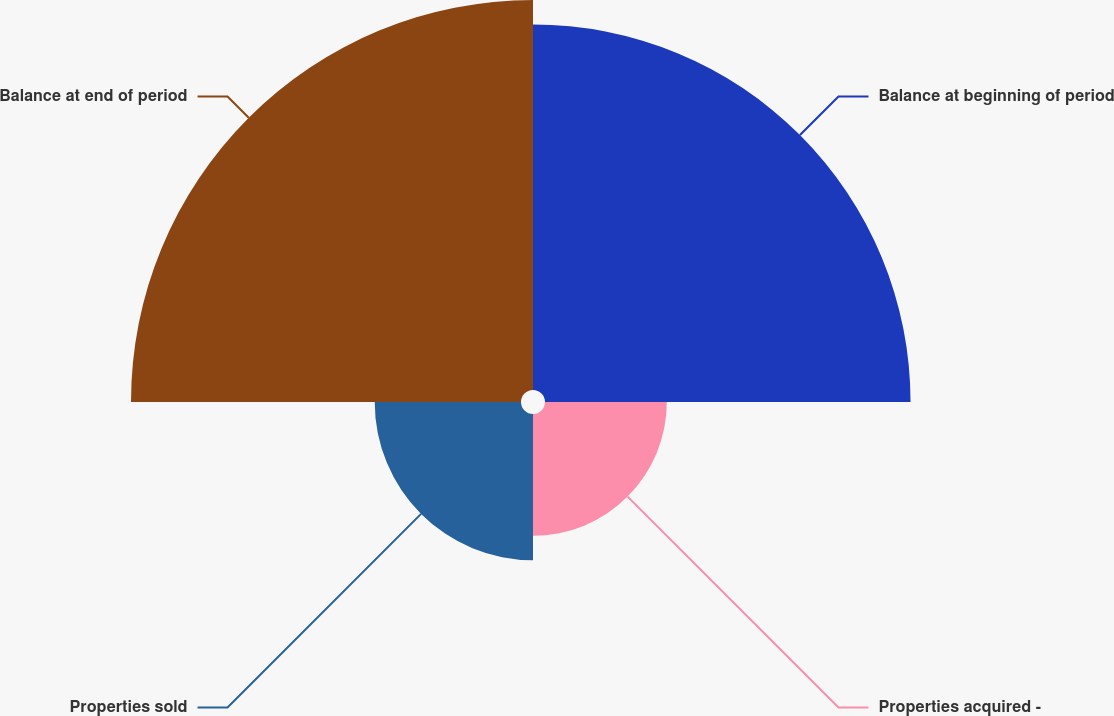Convert chart to OTSL. <chart><loc_0><loc_0><loc_500><loc_500><pie_chart><fcel>Balance at beginning of period<fcel>Properties acquired -<fcel>Properties sold<fcel>Balance at end of period<nl><fcel>35.71%<fcel>11.9%<fcel>14.29%<fcel>38.1%<nl></chart> 